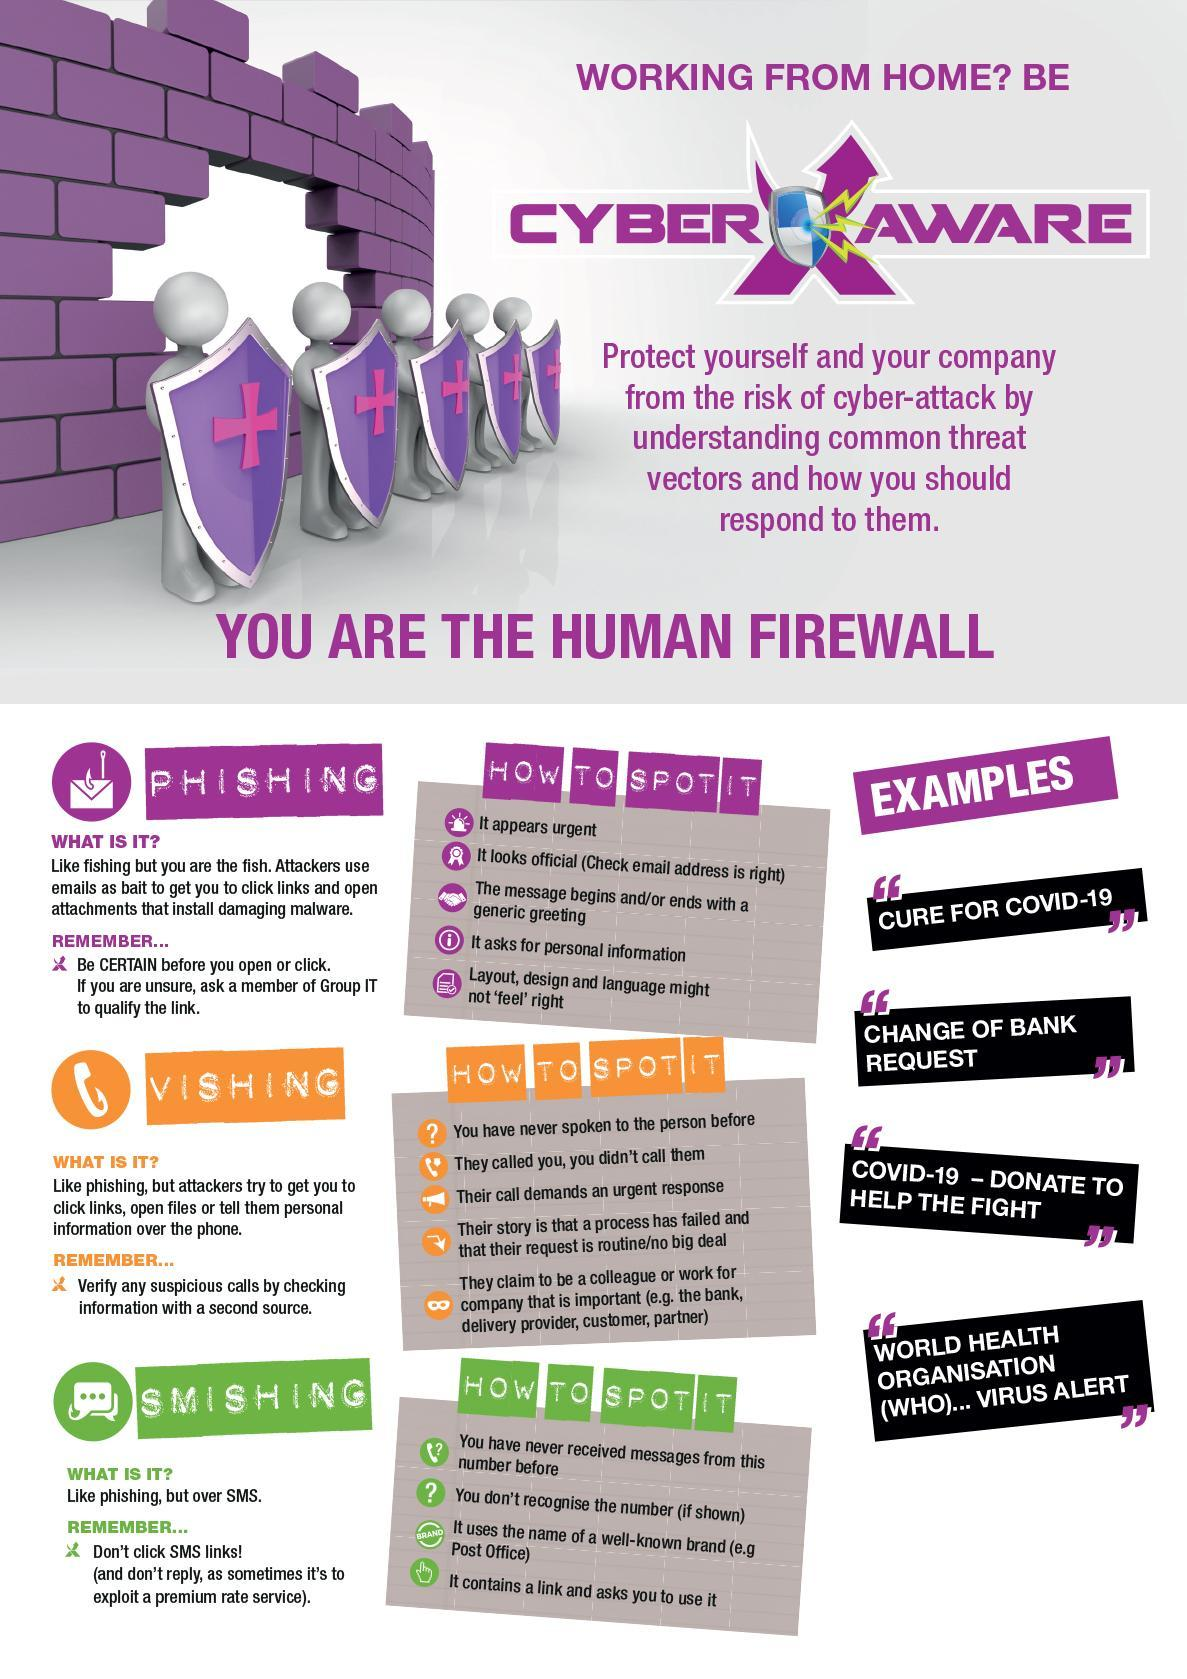How many ways have the infographics listed to spot Smishing?
Answer the question with a short phrase. 4 How many ways have the infographics listed to spot Vishing? 5 What is phishing via SMS called? Smishing How many ways have the infographics listed to spot Phishing? 5 